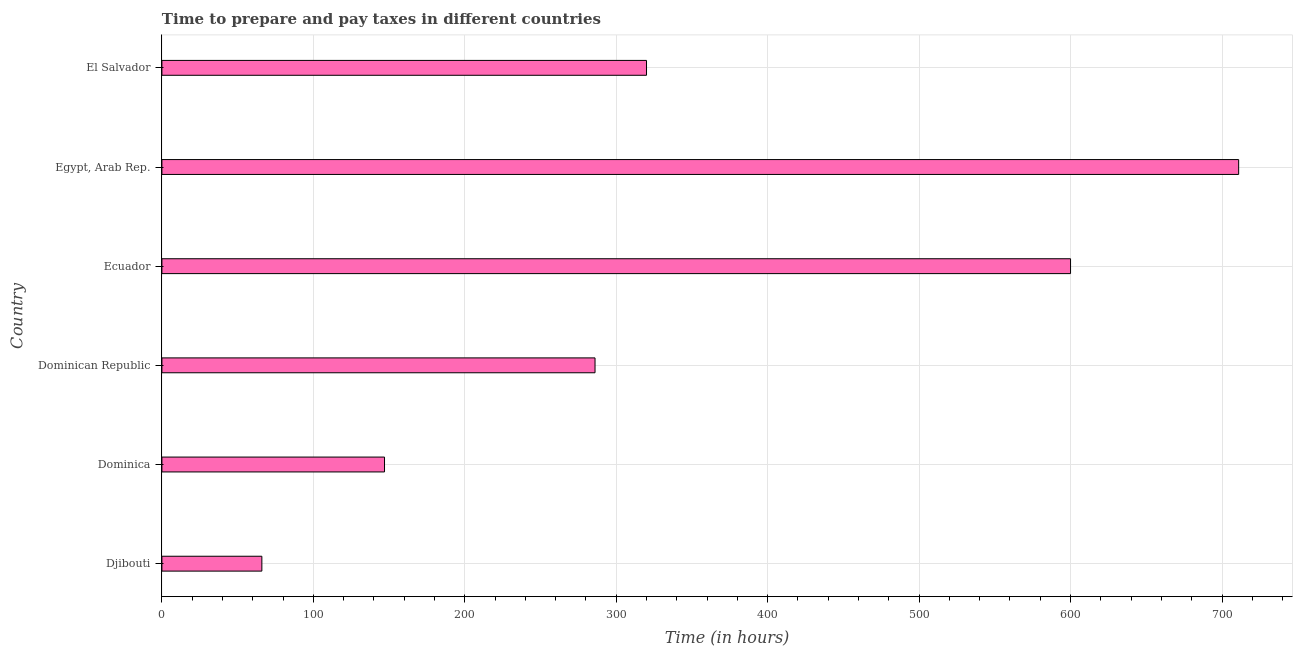Does the graph contain any zero values?
Offer a very short reply. No. Does the graph contain grids?
Your response must be concise. Yes. What is the title of the graph?
Your answer should be compact. Time to prepare and pay taxes in different countries. What is the label or title of the X-axis?
Make the answer very short. Time (in hours). What is the label or title of the Y-axis?
Give a very brief answer. Country. Across all countries, what is the maximum time to prepare and pay taxes?
Offer a very short reply. 711. In which country was the time to prepare and pay taxes maximum?
Offer a terse response. Egypt, Arab Rep. In which country was the time to prepare and pay taxes minimum?
Give a very brief answer. Djibouti. What is the sum of the time to prepare and pay taxes?
Keep it short and to the point. 2130. What is the difference between the time to prepare and pay taxes in Dominican Republic and Egypt, Arab Rep.?
Make the answer very short. -425. What is the average time to prepare and pay taxes per country?
Give a very brief answer. 355. What is the median time to prepare and pay taxes?
Give a very brief answer. 303. In how many countries, is the time to prepare and pay taxes greater than 160 hours?
Keep it short and to the point. 4. What is the ratio of the time to prepare and pay taxes in Dominica to that in Ecuador?
Provide a short and direct response. 0.24. Is the difference between the time to prepare and pay taxes in Dominica and Ecuador greater than the difference between any two countries?
Provide a succinct answer. No. What is the difference between the highest and the second highest time to prepare and pay taxes?
Offer a very short reply. 111. Is the sum of the time to prepare and pay taxes in Dominican Republic and Ecuador greater than the maximum time to prepare and pay taxes across all countries?
Your answer should be very brief. Yes. What is the difference between the highest and the lowest time to prepare and pay taxes?
Make the answer very short. 645. How many countries are there in the graph?
Your answer should be very brief. 6. What is the Time (in hours) of Djibouti?
Give a very brief answer. 66. What is the Time (in hours) in Dominica?
Your answer should be compact. 147. What is the Time (in hours) of Dominican Republic?
Provide a succinct answer. 286. What is the Time (in hours) in Ecuador?
Offer a terse response. 600. What is the Time (in hours) in Egypt, Arab Rep.?
Provide a succinct answer. 711. What is the Time (in hours) of El Salvador?
Ensure brevity in your answer.  320. What is the difference between the Time (in hours) in Djibouti and Dominica?
Keep it short and to the point. -81. What is the difference between the Time (in hours) in Djibouti and Dominican Republic?
Make the answer very short. -220. What is the difference between the Time (in hours) in Djibouti and Ecuador?
Keep it short and to the point. -534. What is the difference between the Time (in hours) in Djibouti and Egypt, Arab Rep.?
Provide a short and direct response. -645. What is the difference between the Time (in hours) in Djibouti and El Salvador?
Offer a terse response. -254. What is the difference between the Time (in hours) in Dominica and Dominican Republic?
Ensure brevity in your answer.  -139. What is the difference between the Time (in hours) in Dominica and Ecuador?
Ensure brevity in your answer.  -453. What is the difference between the Time (in hours) in Dominica and Egypt, Arab Rep.?
Your response must be concise. -564. What is the difference between the Time (in hours) in Dominica and El Salvador?
Make the answer very short. -173. What is the difference between the Time (in hours) in Dominican Republic and Ecuador?
Give a very brief answer. -314. What is the difference between the Time (in hours) in Dominican Republic and Egypt, Arab Rep.?
Your answer should be very brief. -425. What is the difference between the Time (in hours) in Dominican Republic and El Salvador?
Your answer should be very brief. -34. What is the difference between the Time (in hours) in Ecuador and Egypt, Arab Rep.?
Your answer should be compact. -111. What is the difference between the Time (in hours) in Ecuador and El Salvador?
Offer a terse response. 280. What is the difference between the Time (in hours) in Egypt, Arab Rep. and El Salvador?
Give a very brief answer. 391. What is the ratio of the Time (in hours) in Djibouti to that in Dominica?
Give a very brief answer. 0.45. What is the ratio of the Time (in hours) in Djibouti to that in Dominican Republic?
Keep it short and to the point. 0.23. What is the ratio of the Time (in hours) in Djibouti to that in Ecuador?
Offer a terse response. 0.11. What is the ratio of the Time (in hours) in Djibouti to that in Egypt, Arab Rep.?
Your answer should be very brief. 0.09. What is the ratio of the Time (in hours) in Djibouti to that in El Salvador?
Your answer should be very brief. 0.21. What is the ratio of the Time (in hours) in Dominica to that in Dominican Republic?
Make the answer very short. 0.51. What is the ratio of the Time (in hours) in Dominica to that in Ecuador?
Ensure brevity in your answer.  0.24. What is the ratio of the Time (in hours) in Dominica to that in Egypt, Arab Rep.?
Provide a short and direct response. 0.21. What is the ratio of the Time (in hours) in Dominica to that in El Salvador?
Your response must be concise. 0.46. What is the ratio of the Time (in hours) in Dominican Republic to that in Ecuador?
Give a very brief answer. 0.48. What is the ratio of the Time (in hours) in Dominican Republic to that in Egypt, Arab Rep.?
Your answer should be compact. 0.4. What is the ratio of the Time (in hours) in Dominican Republic to that in El Salvador?
Provide a succinct answer. 0.89. What is the ratio of the Time (in hours) in Ecuador to that in Egypt, Arab Rep.?
Keep it short and to the point. 0.84. What is the ratio of the Time (in hours) in Ecuador to that in El Salvador?
Keep it short and to the point. 1.88. What is the ratio of the Time (in hours) in Egypt, Arab Rep. to that in El Salvador?
Make the answer very short. 2.22. 